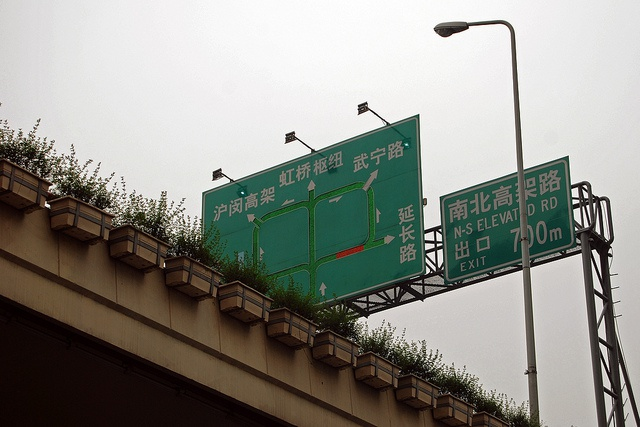Describe the objects in this image and their specific colors. I can see potted plant in lightgray, black, maroon, and gray tones, potted plant in lightgray, black, and maroon tones, potted plant in lightgray, black, maroon, and gray tones, potted plant in lightgray, black, darkgreen, and maroon tones, and potted plant in lightgray, black, maroon, and darkgreen tones in this image. 